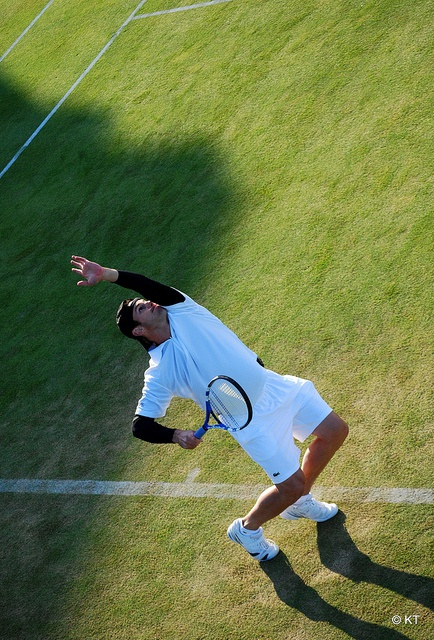Describe the objects in this image and their specific colors. I can see people in olive, lightblue, and black tones and tennis racket in olive, lightblue, black, and gray tones in this image. 